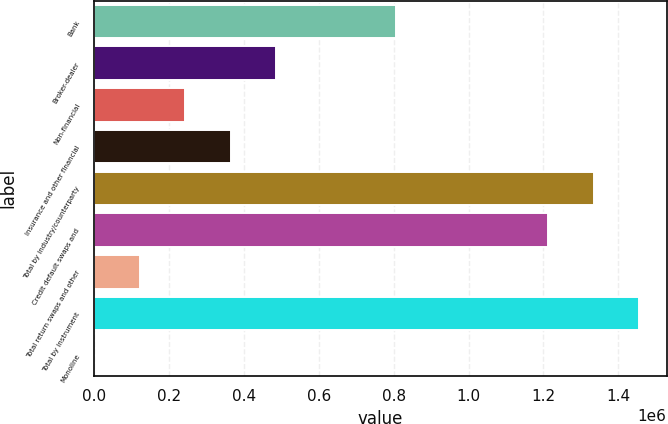<chart> <loc_0><loc_0><loc_500><loc_500><bar_chart><fcel>Bank<fcel>Broker-dealer<fcel>Non-financial<fcel>Insurance and other financial<fcel>Total by industry/counterparty<fcel>Credit default swaps and<fcel>Total return swaps and other<fcel>Total by instrument<fcel>Monoline<nl><fcel>807484<fcel>485705<fcel>242922<fcel>364313<fcel>1.3346e+06<fcel>1.21321e+06<fcel>121530<fcel>1.45599e+06<fcel>139<nl></chart> 